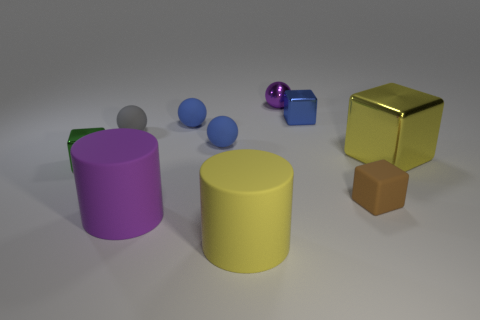Is there a pattern or layout to how the objects are arranged in the image? The objects seem to be arranged randomly with no discernible pattern. The placement appears haphazard with different shapes, sizes, and colors of objects scattered across a flat surface, against a neutral background. 